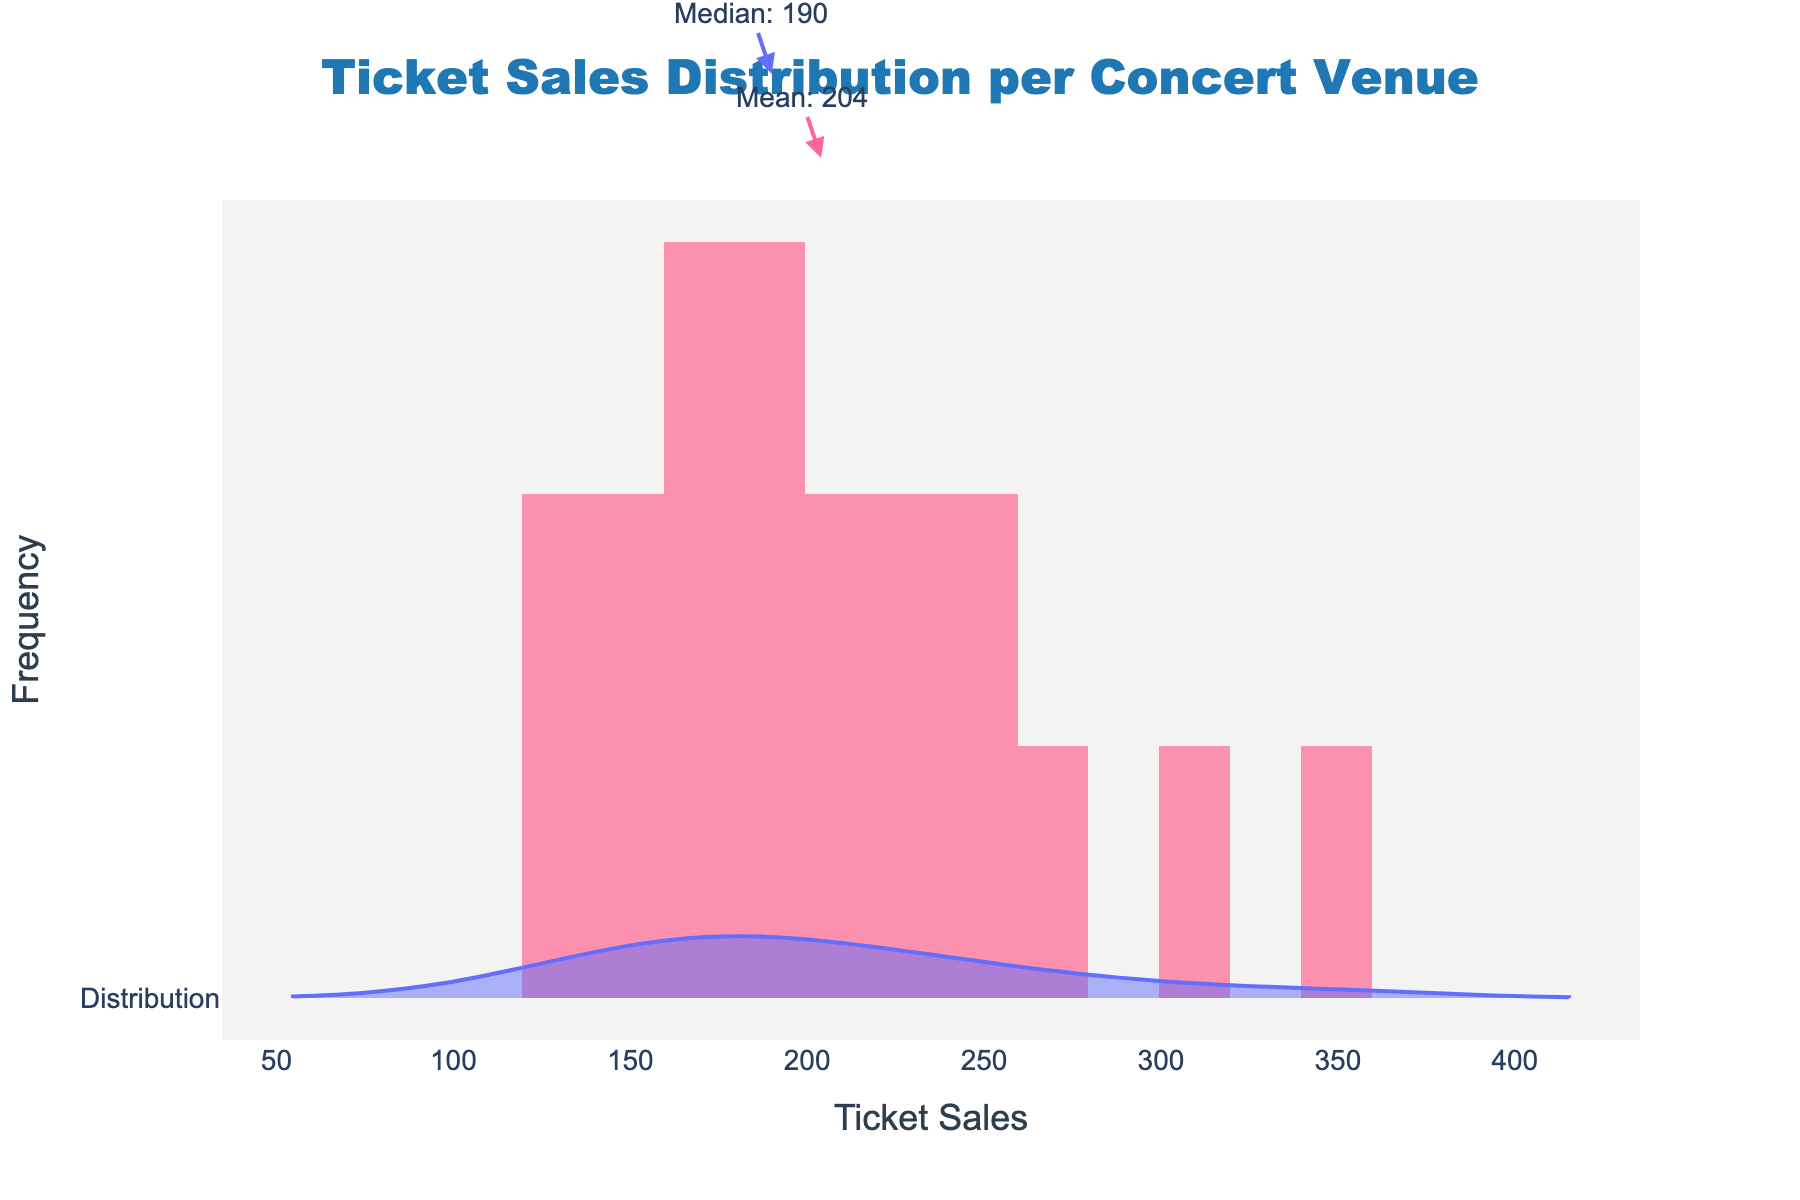What's the title of the figure? The title is usually located at the top center of the figure. Reading it directly gives "Ticket Sales Distribution per Concert Venue"
Answer: Ticket Sales Distribution per Concert Venue What is the mean ticket sales value? The mean value is denoted by an annotation on the figure, which refers to the arrow pointing towards the mean. The annotation states the mean as "Mean: 202"
Answer: 202 What is the median ticket sales value? The median value is denoted by another annotation, which refers to the arrow pointing towards the median value on the figure. The annotation states the median as "Median: 190"
Answer: 190 Which venues have higher ticket sales than the mean? Identifying venues with ticket sales higher than the mean involves looking at the annotated mean value (202) and comparing it to the list of venues and their sales. Those higher than 202 are The Wiltern (250), Hollywood Bowl (300), Greek Theatre (275), Staples Center (350), Microsoft Theater (220), Paladium (230), and The Shrine (240)
Answer: The Wiltern, Hollywood Bowl, Greek Theatre, Staples Center, Microsoft Theater, Paladium, The Shrine How many venues have ticket sales less than the median? The median sales value is 190. To find venues with ticket sales less than 190: The Roxy (150), Troubadour (170), The Echo (120), The Regent (160), Whisky a Go Go (140), Viper Room (135), Teragram Ballroom (175)
Answer: 7 What is the ticket sales value for the venue with the highest sales? The highest sales can be identified by looking at the highest point on the x-axis and the corresponding values. The venue with the maximum ticket sales value listed is Staples Center with 350
Answer: 350 Between which two venues is the biggest difference in ticket sales observed? To find the biggest difference, look for the highest and lowest values in the ticket sales data. The highest is Staples Center (350) and the lowest is The Echo (120). The difference is 350 - 120 = 230
Answer: 230 What is the color of the histogram bars? The color of the histogram bars can be seen visually in the figure. The histogram bars are colored in a pink hue
Answer: Pink Are the histogram bars overlapping with the violin plot? By observing the overlap region in the figure, we can see that the histogram and violin plots are overlaid over the same x-axis range, indicating they overlap visually
Answer: Yes Which ticket sales value is more frequent: 150 or 200? To determine frequency, observe the height of bars at 150 and 200. The taller bar corresponds to the more frequent value. By visualizing the height of the bars, it is clear that 150 has a taller bar
Answer: 150 